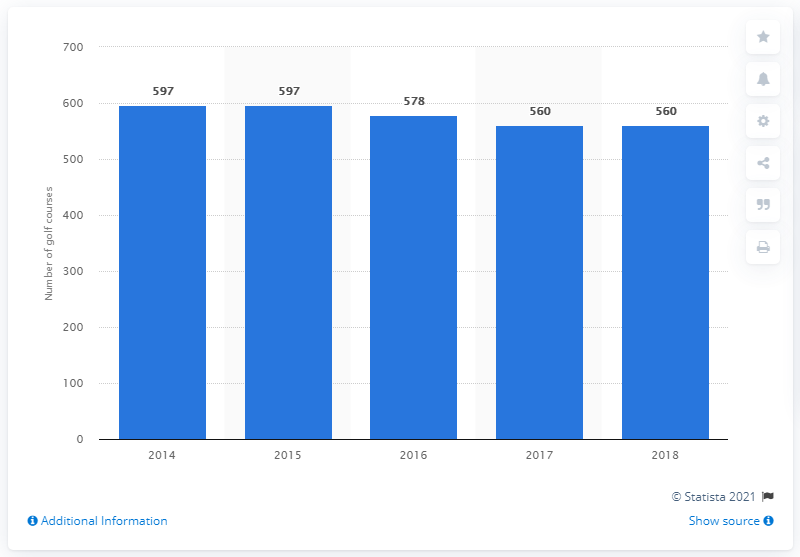How many golf courses were there in Scotland in 2018? As of 2018, Scotland was home to 560 golf courses, offering a rich variety of playing experiences, from historic links to parkland and heathland courses, reflecting the storied history and tradition of the sport in the country. 